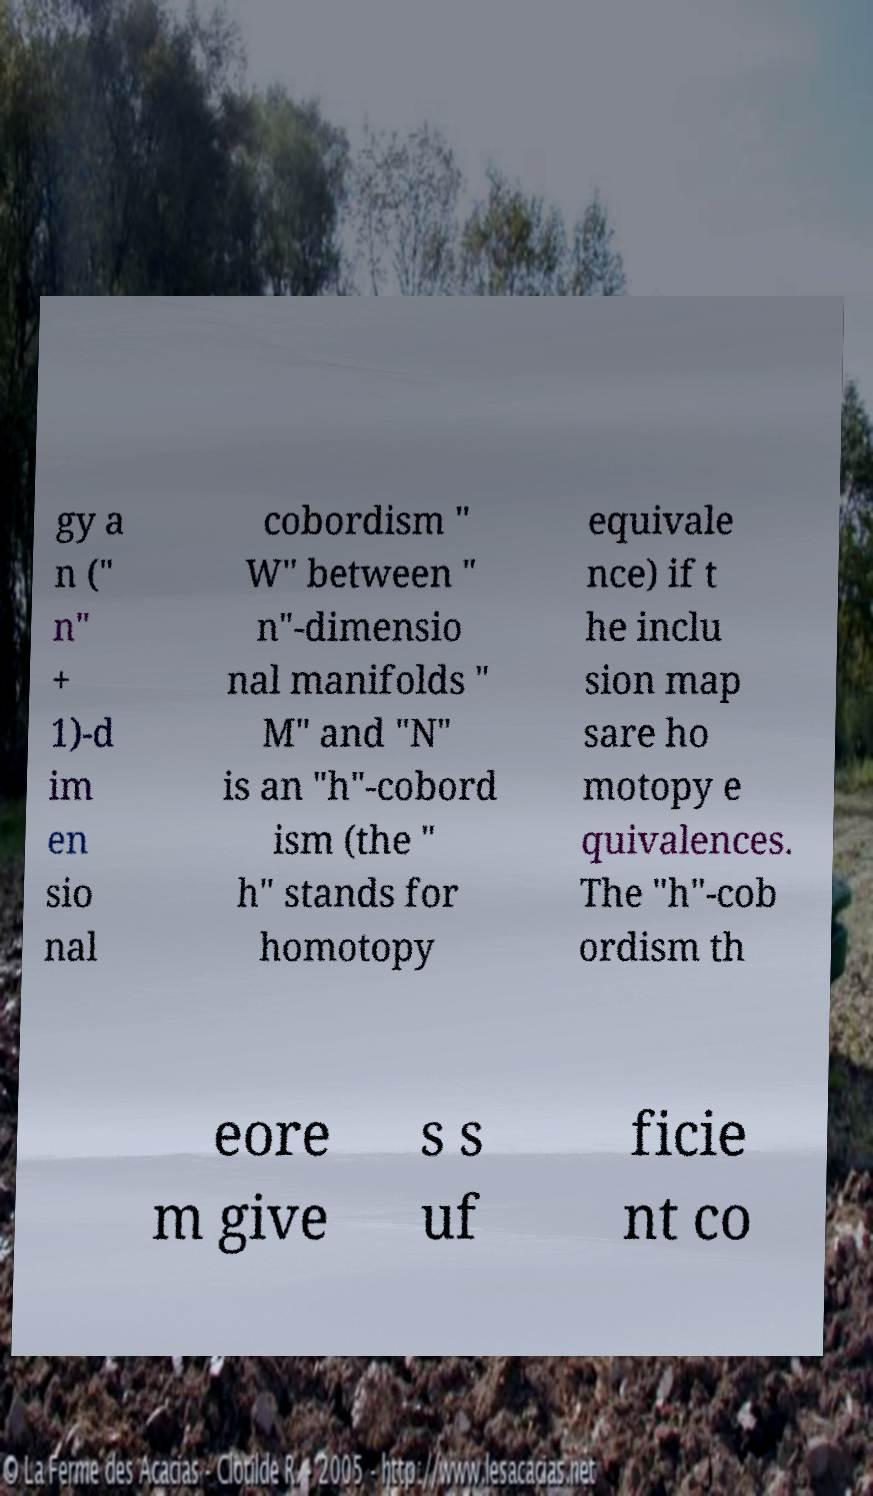I need the written content from this picture converted into text. Can you do that? gy a n (" n" + 1)-d im en sio nal cobordism " W" between " n"-dimensio nal manifolds " M" and "N" is an "h"-cobord ism (the " h" stands for homotopy equivale nce) if t he inclu sion map sare ho motopy e quivalences. The "h"-cob ordism th eore m give s s uf ficie nt co 